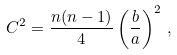Convert formula to latex. <formula><loc_0><loc_0><loc_500><loc_500>C ^ { 2 } = \frac { n ( n - 1 ) } { 4 } \left ( \frac { b } { a } \right ) ^ { 2 } \, ,</formula> 